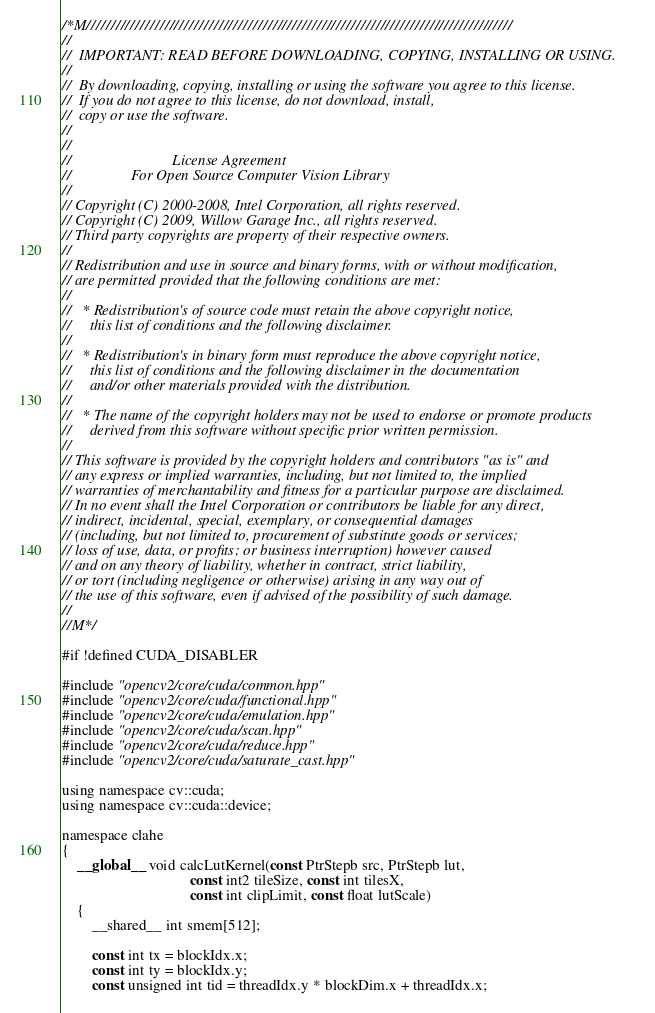Convert code to text. <code><loc_0><loc_0><loc_500><loc_500><_Cuda_>/*M///////////////////////////////////////////////////////////////////////////////////////
//
//  IMPORTANT: READ BEFORE DOWNLOADING, COPYING, INSTALLING OR USING.
//
//  By downloading, copying, installing or using the software you agree to this license.
//  If you do not agree to this license, do not download, install,
//  copy or use the software.
//
//
//                           License Agreement
//                For Open Source Computer Vision Library
//
// Copyright (C) 2000-2008, Intel Corporation, all rights reserved.
// Copyright (C) 2009, Willow Garage Inc., all rights reserved.
// Third party copyrights are property of their respective owners.
//
// Redistribution and use in source and binary forms, with or without modification,
// are permitted provided that the following conditions are met:
//
//   * Redistribution's of source code must retain the above copyright notice,
//     this list of conditions and the following disclaimer.
//
//   * Redistribution's in binary form must reproduce the above copyright notice,
//     this list of conditions and the following disclaimer in the documentation
//     and/or other materials provided with the distribution.
//
//   * The name of the copyright holders may not be used to endorse or promote products
//     derived from this software without specific prior written permission.
//
// This software is provided by the copyright holders and contributors "as is" and
// any express or implied warranties, including, but not limited to, the implied
// warranties of merchantability and fitness for a particular purpose are disclaimed.
// In no event shall the Intel Corporation or contributors be liable for any direct,
// indirect, incidental, special, exemplary, or consequential damages
// (including, but not limited to, procurement of substitute goods or services;
// loss of use, data, or profits; or business interruption) however caused
// and on any theory of liability, whether in contract, strict liability,
// or tort (including negligence or otherwise) arising in any way out of
// the use of this software, even if advised of the possibility of such damage.
//
//M*/

#if !defined CUDA_DISABLER

#include "opencv2/core/cuda/common.hpp"
#include "opencv2/core/cuda/functional.hpp"
#include "opencv2/core/cuda/emulation.hpp"
#include "opencv2/core/cuda/scan.hpp"
#include "opencv2/core/cuda/reduce.hpp"
#include "opencv2/core/cuda/saturate_cast.hpp"

using namespace cv::cuda;
using namespace cv::cuda::device;

namespace clahe
{
    __global__ void calcLutKernel(const PtrStepb src, PtrStepb lut,
                                  const int2 tileSize, const int tilesX,
                                  const int clipLimit, const float lutScale)
    {
        __shared__ int smem[512];

        const int tx = blockIdx.x;
        const int ty = blockIdx.y;
        const unsigned int tid = threadIdx.y * blockDim.x + threadIdx.x;
</code> 